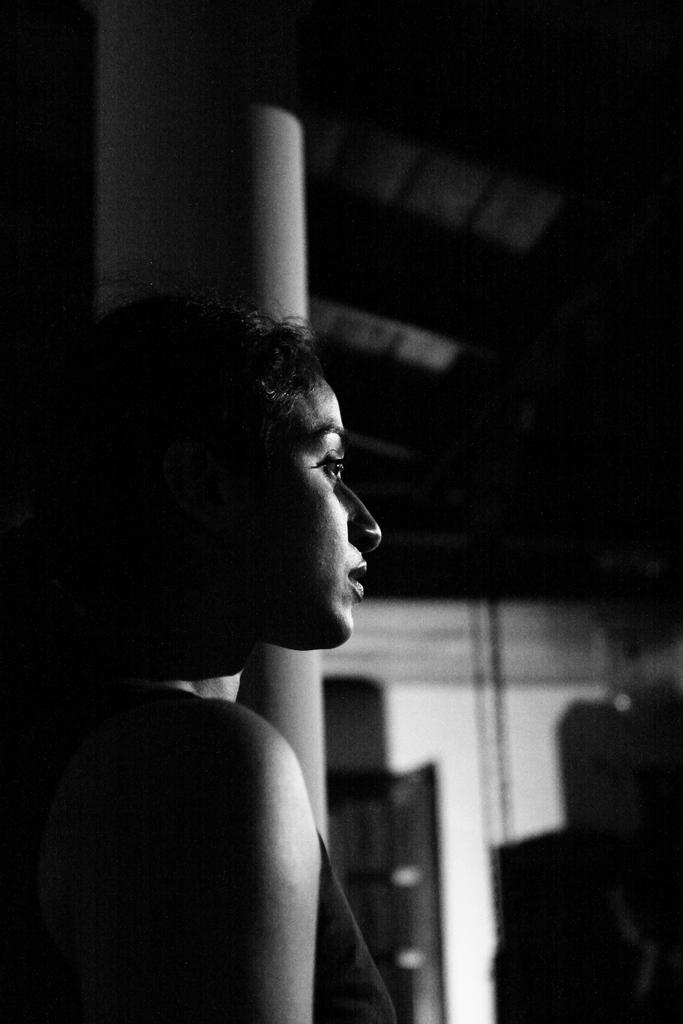What is the main subject of the image? There is a person standing in the center of the image. What can be seen in the background of the image? There is a wall, a roof, a door, and a pillar in the background of the image. Are there any other objects visible in the background? Yes, there are a few other objects in the background of the image. What type of peace is being promoted in the image? There is no indication of peace promotion in the image; it simply shows a person standing in front of a background with various structures and objects. 